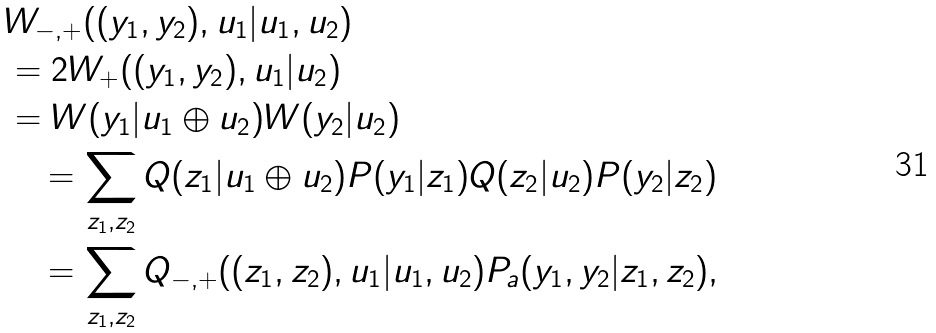Convert formula to latex. <formula><loc_0><loc_0><loc_500><loc_500>& W _ { - , + } ( ( y _ { 1 } , y _ { 2 } ) , u _ { 1 } | u _ { 1 } , u _ { 2 } ) \\ & = 2 W _ { + } ( ( y _ { 1 } , y _ { 2 } ) , u _ { 1 } | u _ { 2 } ) \\ & = W ( y _ { 1 } | u _ { 1 } \oplus u _ { 2 } ) W ( y _ { 2 } | u _ { 2 } ) \\ & \quad = \sum _ { z _ { 1 } , z _ { 2 } } Q ( z _ { 1 } | u _ { 1 } \oplus u _ { 2 } ) P ( y _ { 1 } | z _ { 1 } ) Q ( z _ { 2 } | u _ { 2 } ) P ( y _ { 2 } | z _ { 2 } ) \\ & \quad = \sum _ { z _ { 1 } , z _ { 2 } } Q _ { - , + } ( ( z _ { 1 } , z _ { 2 } ) , u _ { 1 } | u _ { 1 } , u _ { 2 } ) P _ { a } ( y _ { 1 } , y _ { 2 } | z _ { 1 } , z _ { 2 } ) ,</formula> 